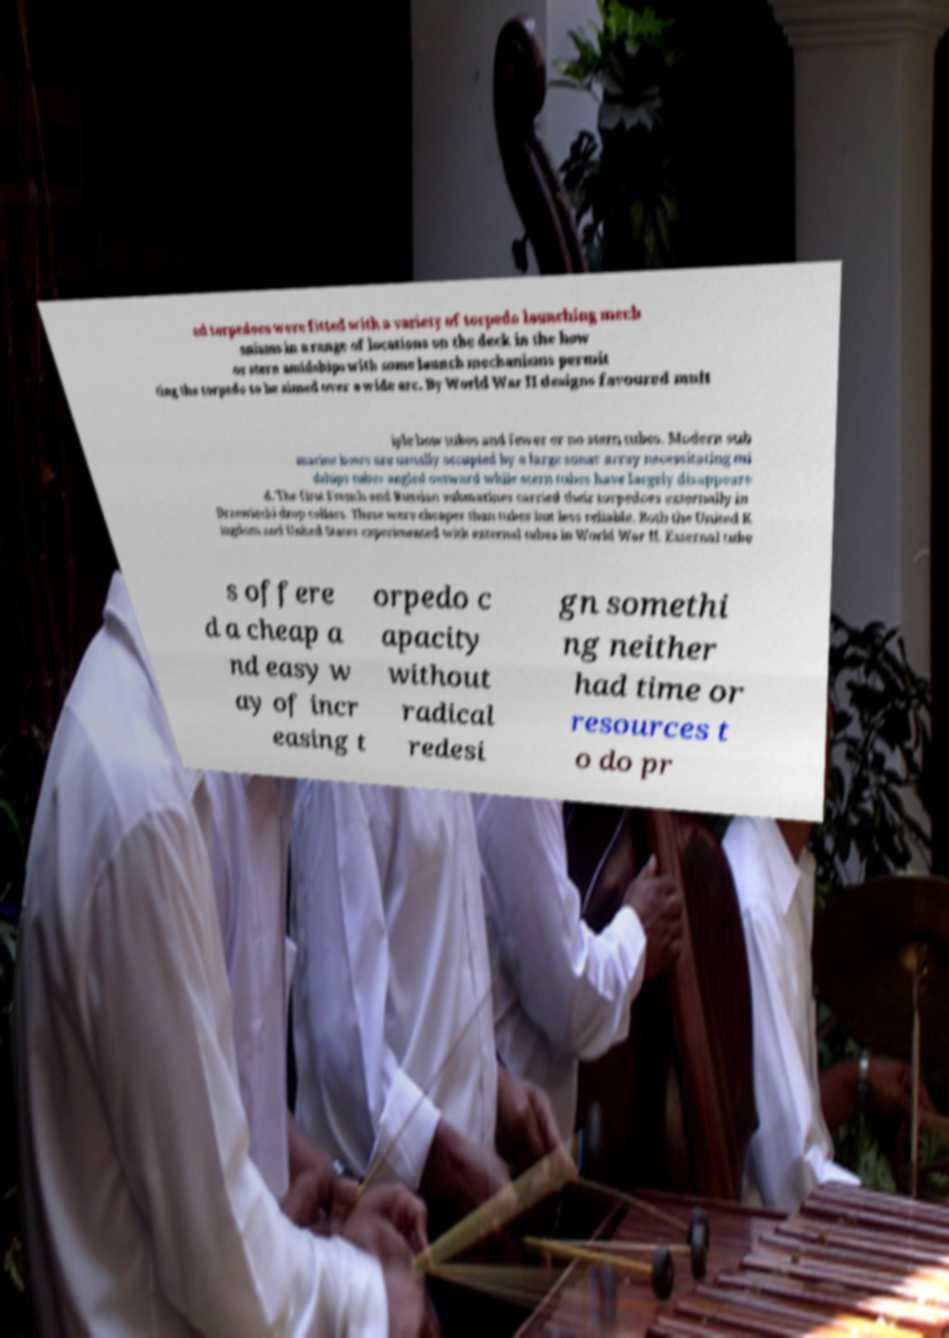Could you assist in decoding the text presented in this image and type it out clearly? ed torpedoes were fitted with a variety of torpedo launching mech anisms in a range of locations on the deck in the bow or stern amidships with some launch mechanisms permit ting the torpedo to be aimed over a wide arc. By World War II designs favoured mult iple bow tubes and fewer or no stern tubes. Modern sub marine bows are usually occupied by a large sonar array necessitating mi dships tubes angled outward while stern tubes have largely disappeare d. The first French and Russian submarines carried their torpedoes externally in Drzewiecki drop collars. These were cheaper than tubes but less reliable. Both the United K ingdom and United States experimented with external tubes in World War II. External tube s offere d a cheap a nd easy w ay of incr easing t orpedo c apacity without radical redesi gn somethi ng neither had time or resources t o do pr 